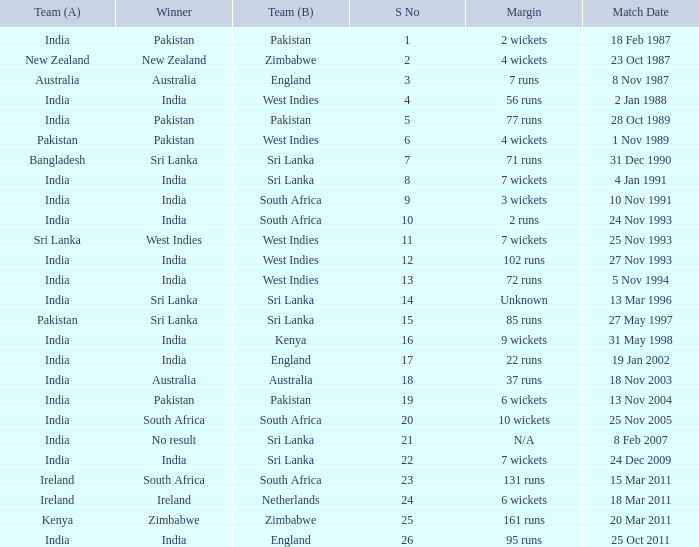What date did the West Indies win the match? 25 Nov 1993. 